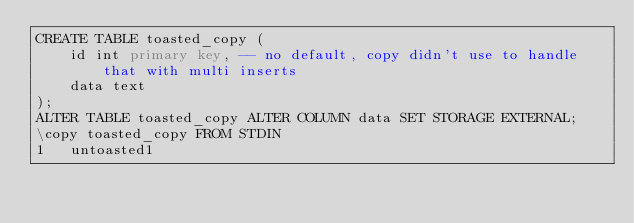Convert code to text. <code><loc_0><loc_0><loc_500><loc_500><_SQL_>CREATE TABLE toasted_copy (
    id int primary key, -- no default, copy didn't use to handle that with multi inserts
    data text
);
ALTER TABLE toasted_copy ALTER COLUMN data SET STORAGE EXTERNAL;
\copy toasted_copy FROM STDIN
1	untoasted1</code> 